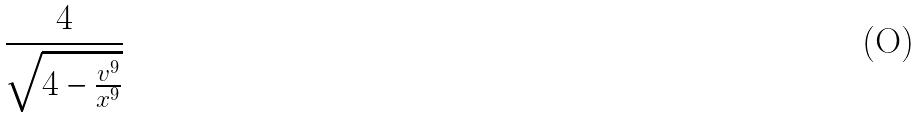<formula> <loc_0><loc_0><loc_500><loc_500>\frac { 4 } { \sqrt { 4 - \frac { v ^ { 9 } } { x ^ { 9 } } } }</formula> 